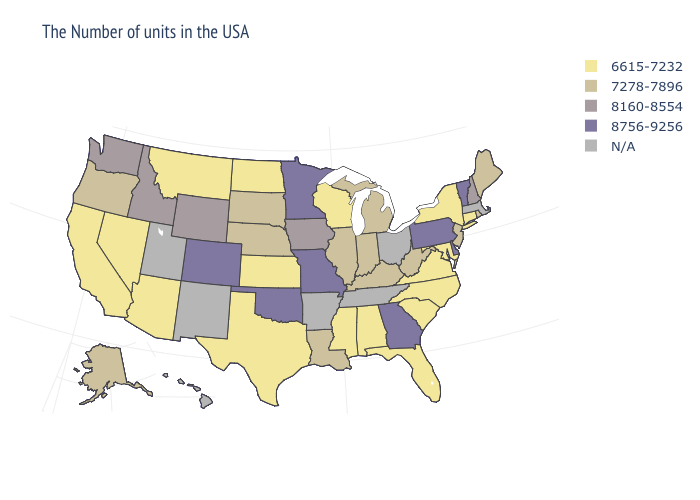Name the states that have a value in the range 8756-9256?
Quick response, please. Vermont, Delaware, Pennsylvania, Georgia, Missouri, Minnesota, Oklahoma, Colorado. What is the value of Colorado?
Quick response, please. 8756-9256. What is the lowest value in the Northeast?
Keep it brief. 6615-7232. What is the value of Utah?
Keep it brief. N/A. Name the states that have a value in the range N/A?
Concise answer only. Massachusetts, Ohio, Tennessee, Arkansas, New Mexico, Utah, Hawaii. Which states have the highest value in the USA?
Answer briefly. Vermont, Delaware, Pennsylvania, Georgia, Missouri, Minnesota, Oklahoma, Colorado. What is the value of North Dakota?
Concise answer only. 6615-7232. Does Oklahoma have the highest value in the South?
Give a very brief answer. Yes. What is the value of South Carolina?
Concise answer only. 6615-7232. Which states have the lowest value in the USA?
Give a very brief answer. Connecticut, New York, Maryland, Virginia, North Carolina, South Carolina, Florida, Alabama, Wisconsin, Mississippi, Kansas, Texas, North Dakota, Montana, Arizona, Nevada, California. What is the value of Rhode Island?
Write a very short answer. 7278-7896. Does Wisconsin have the lowest value in the MidWest?
Concise answer only. Yes. What is the value of Colorado?
Be succinct. 8756-9256. Is the legend a continuous bar?
Give a very brief answer. No. 